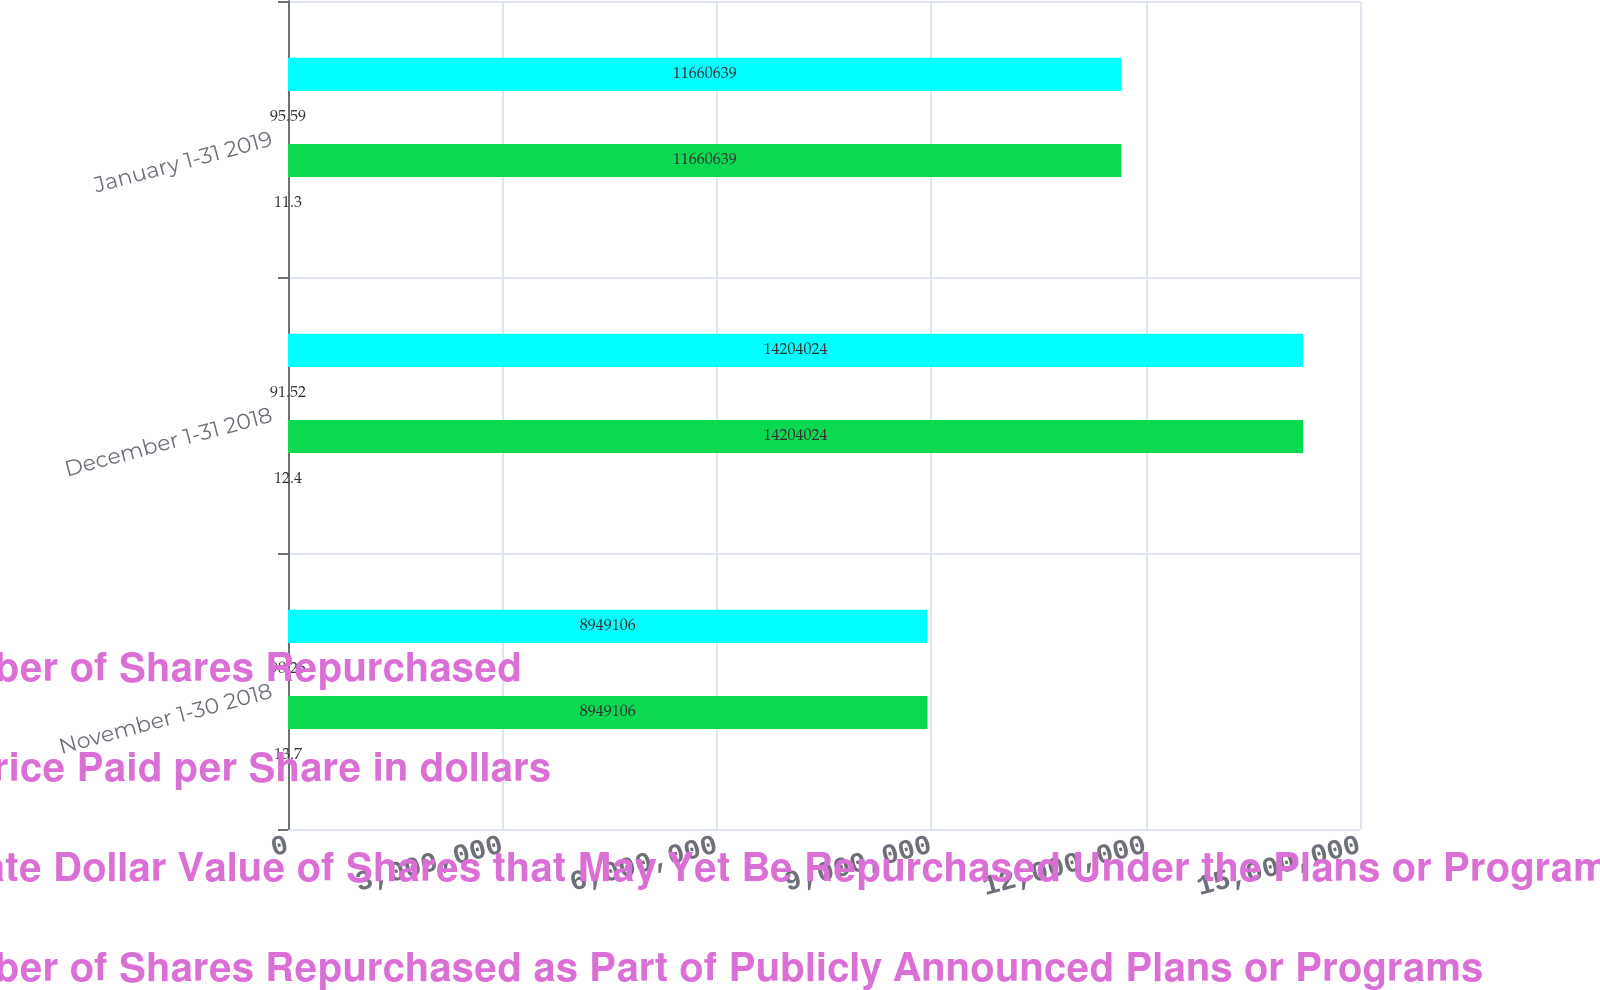Convert chart. <chart><loc_0><loc_0><loc_500><loc_500><stacked_bar_chart><ecel><fcel>November 1-30 2018<fcel>December 1-31 2018<fcel>January 1-31 2019<nl><fcel>Total Number of Shares Repurchased<fcel>8.94911e+06<fcel>1.4204e+07<fcel>1.16606e+07<nl><fcel>Average Price Paid per Share in dollars<fcel>98.25<fcel>91.52<fcel>95.59<nl><fcel>Approximate Dollar Value of Shares that May Yet Be Repurchased Under the Plans or Programs 1 in billions<fcel>8.94911e+06<fcel>1.4204e+07<fcel>1.16606e+07<nl><fcel>Total Number of Shares Repurchased as Part of Publicly Announced Plans or Programs<fcel>13.7<fcel>12.4<fcel>11.3<nl></chart> 